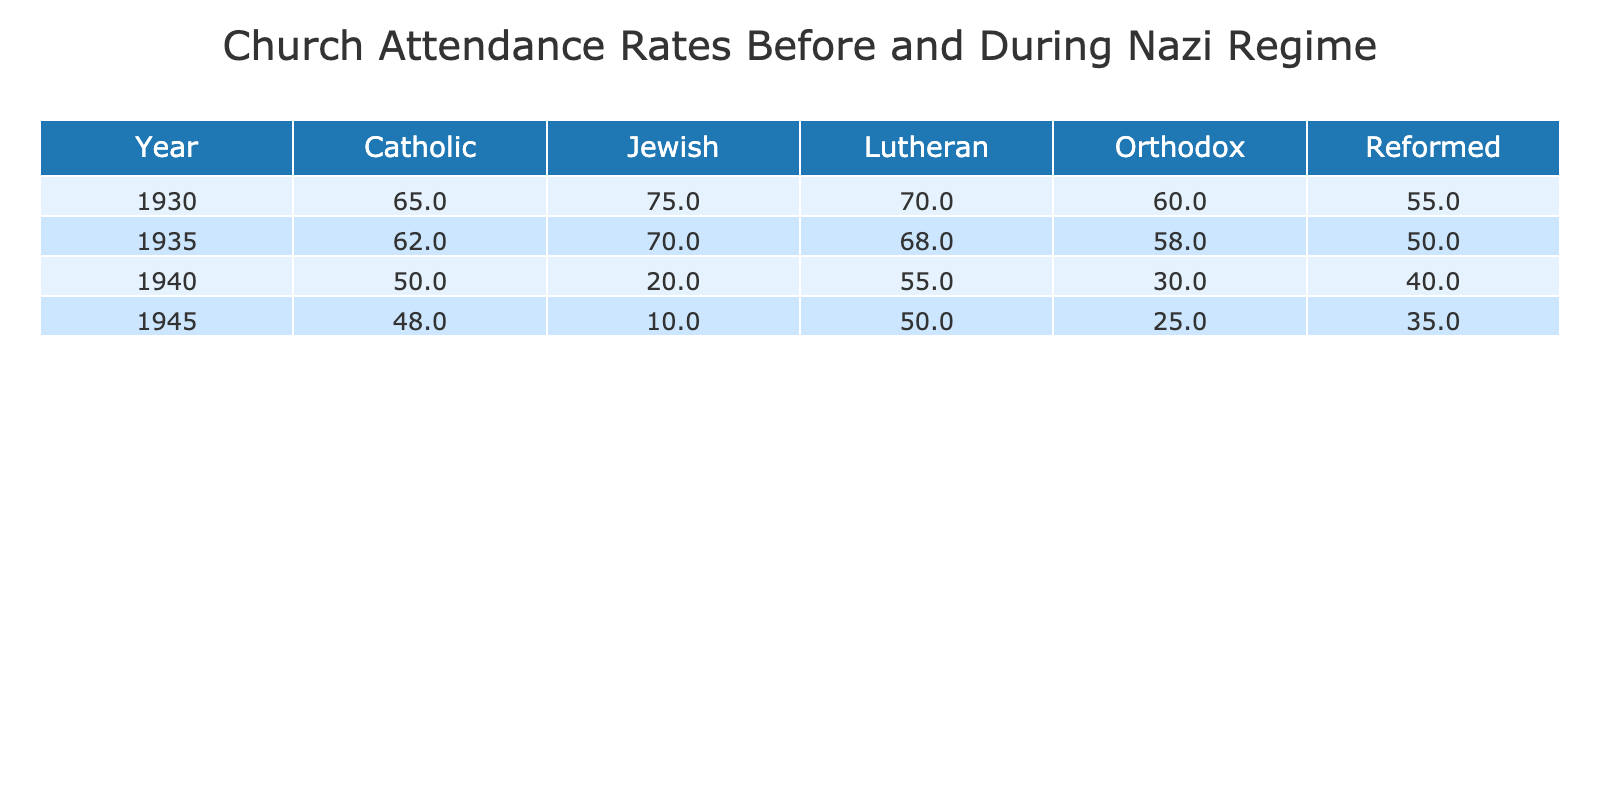What was the attendance rate for Lutheran churches in 1945? Referring to the 1945 row in the table, the attendance rate percentage for Lutheran churches is 50.
Answer: 50 What was the highest church attendance rate recorded and in which year and denomination did it occur? Looking through the table, the highest attendance rate recorded is 75% for Jewish churches in the year 1930.
Answer: 75% in 1930 Jewish What is the percentage change in attendance rate for Orthodox churches from 1930 to 1940? For Orthodox churches in 1930, the attendance rate was 60, and by 1940, it fell to 30. The percentage change is calculated as ((30 - 60) / 60) * 100 = -50%.
Answer: -50% Did Catholic church attendance decrease from 1930 to 1945? Yes, the attendance rate for Catholic churches decreased from 65 in 1930 to 48 in 1945, indicating a decline.
Answer: Yes What is the average attendance rate for Reformed churches across all the years provided? The attendance rates for Reformed churches are 55 (1930), 50 (1935), 40 (1940), and 35 (1945). Adding these gives 55 + 50 + 40 + 35 = 180. There are 4 years, so the average is 180 / 4 = 45.
Answer: 45 Which denomination had the most significant decline in attendance rate from 1930 to 1945, and what was that decline? Analyzing the data, Jewish attendance was 75 in 1930 and dropped to 10 in 1945, resulting in a decline of 75 - 10 = 65. This is greater than any other denomination's decline.
Answer: Jewish with a decline of 65 What was the attendance rate for Catholic churches in 1940 compared to other years? The attendance rate for Catholic churches in 1940 was 50. Comparing this with previous years: 65 (1930) and 62 (1935), it's the lowest at that point.
Answer: Lowest Is it true that the attendance rate for all denominations decreased from 1930 to 1945? Not true. While most denominations, including Catholic, Lutheran, Reformed, and Jewish, experienced declines, the Orthodox churches' attendance rate also decreased. However, Jewish attendance did not reflect a consistent decline over all years.
Answer: False 